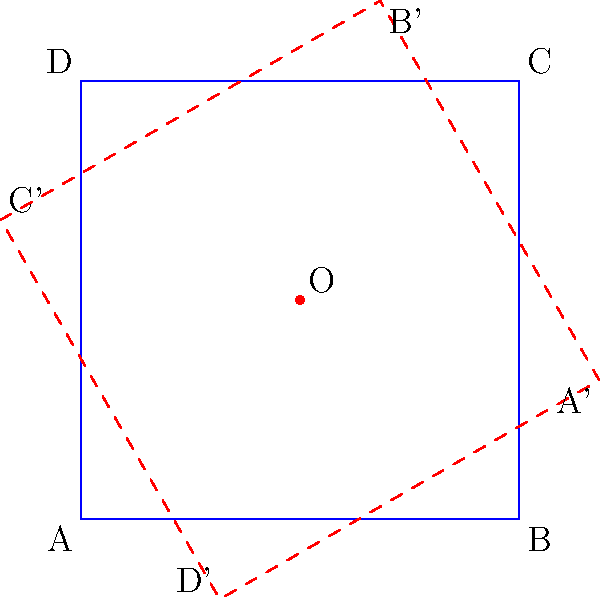In your fantasy novel, you're describing a magical portal created by rotating a square-shaped rune. The rune is represented by the blue square ABCD with side length 2 units, and the center of rotation O is at (1,1). If the rune is rotated 120° counterclockwise around point O to create the portal (shown as the red dashed square), what are the coordinates of point C' (the rotated position of C)? To find the coordinates of C' after rotating point C by 120° counterclockwise around point O, we can follow these steps:

1. Identify the initial coordinates:
   Point C: (2, 2)
   Point O (center of rotation): (1, 1)

2. Translate the coordinate system so that O is at the origin:
   C relative to O: (2-1, 2-1) = (1, 1)

3. Apply the rotation matrix for 120° counterclockwise rotation:
   $$R_{120°} = \begin{pmatrix} 
   -\frac{1}{2} & -\frac{\sqrt{3}}{2} \\
   \frac{\sqrt{3}}{2} & -\frac{1}{2}
   \end{pmatrix}$$

4. Multiply the rotation matrix by the translated coordinates:
   $$\begin{pmatrix} 
   -\frac{1}{2} & -\frac{\sqrt{3}}{2} \\
   \frac{\sqrt{3}}{2} & -\frac{1}{2}
   \end{pmatrix} \cdot \begin{pmatrix} 
   1 \\ 1
   \end{pmatrix} = \begin{pmatrix} 
   -\frac{1}{2} - \frac{\sqrt{3}}{2} \\
   \frac{\sqrt{3}}{2} - \frac{1}{2}
   \end{pmatrix}$$

5. Translate the result back to the original coordinate system:
   C': $(1 + (-\frac{1}{2} - \frac{\sqrt{3}}{2}), 1 + (\frac{\sqrt{3}}{2} - \frac{1}{2}))$
   
   Simplifying:
   C': $(0.5 - \frac{\sqrt{3}}{2}, 0.5 + \frac{\sqrt{3}}{2})$

Therefore, the coordinates of C' are $(0.5 - \frac{\sqrt{3}}{2}, 0.5 + \frac{\sqrt{3}}{2})$.
Answer: $(0.5 - \frac{\sqrt{3}}{2}, 0.5 + \frac{\sqrt{3}}{2})$ 